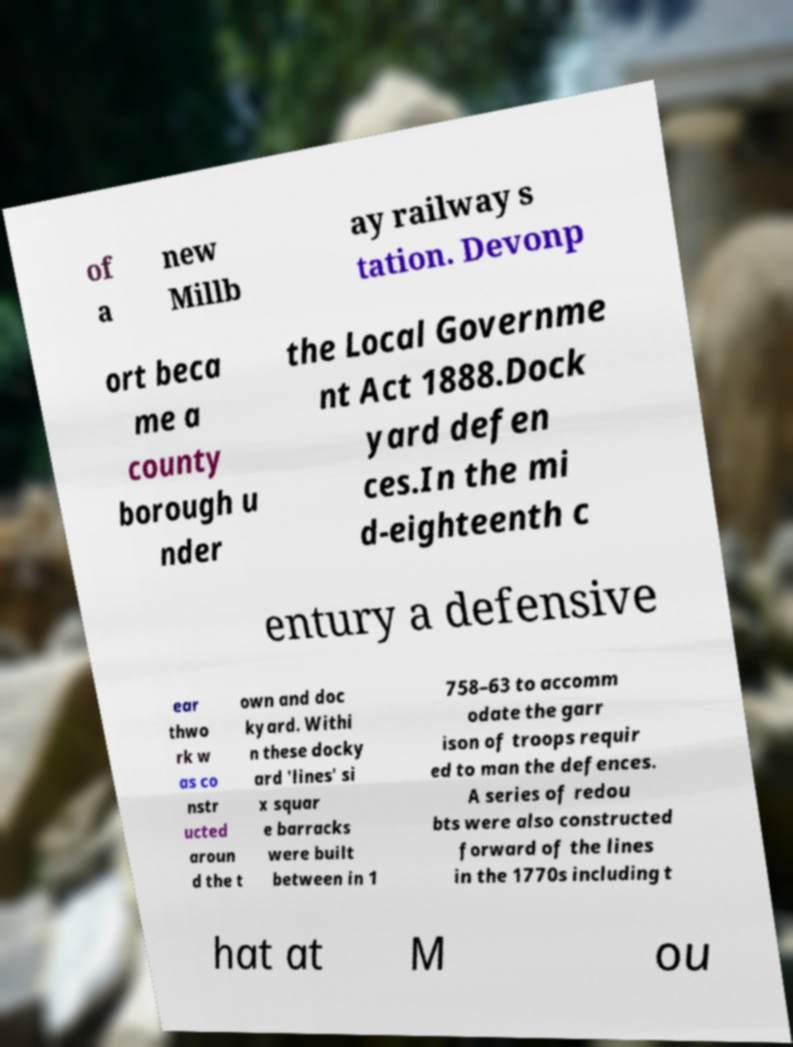Can you accurately transcribe the text from the provided image for me? of a new Millb ay railway s tation. Devonp ort beca me a county borough u nder the Local Governme nt Act 1888.Dock yard defen ces.In the mi d-eighteenth c entury a defensive ear thwo rk w as co nstr ucted aroun d the t own and doc kyard. Withi n these docky ard 'lines' si x squar e barracks were built between in 1 758–63 to accomm odate the garr ison of troops requir ed to man the defences. A series of redou bts were also constructed forward of the lines in the 1770s including t hat at M ou 